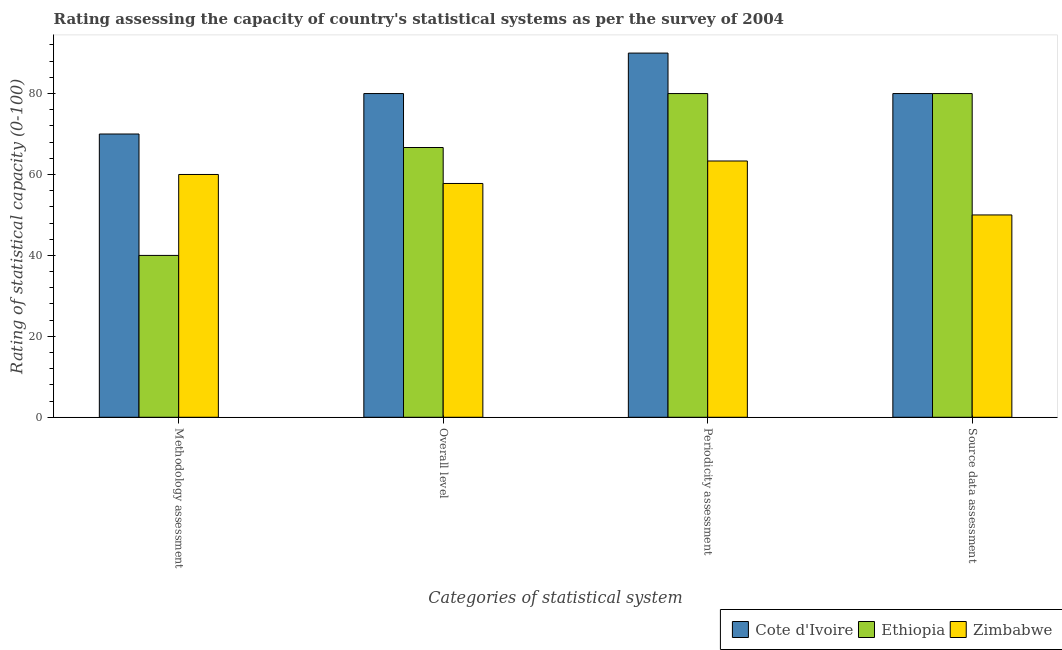How many groups of bars are there?
Provide a succinct answer. 4. Are the number of bars on each tick of the X-axis equal?
Your answer should be compact. Yes. What is the label of the 1st group of bars from the left?
Provide a succinct answer. Methodology assessment. What is the overall level rating in Ethiopia?
Keep it short and to the point. 66.67. Across all countries, what is the maximum source data assessment rating?
Make the answer very short. 80. Across all countries, what is the minimum source data assessment rating?
Provide a short and direct response. 50. In which country was the methodology assessment rating maximum?
Ensure brevity in your answer.  Cote d'Ivoire. In which country was the source data assessment rating minimum?
Your response must be concise. Zimbabwe. What is the total periodicity assessment rating in the graph?
Give a very brief answer. 233.33. What is the difference between the periodicity assessment rating in Ethiopia and that in Zimbabwe?
Provide a succinct answer. 16.67. What is the average source data assessment rating per country?
Offer a very short reply. 70. Is the difference between the periodicity assessment rating in Zimbabwe and Cote d'Ivoire greater than the difference between the overall level rating in Zimbabwe and Cote d'Ivoire?
Ensure brevity in your answer.  No. What is the difference between the highest and the second highest overall level rating?
Provide a succinct answer. 13.33. What is the difference between the highest and the lowest overall level rating?
Offer a very short reply. 22.22. In how many countries, is the source data assessment rating greater than the average source data assessment rating taken over all countries?
Your answer should be compact. 2. What does the 2nd bar from the left in Source data assessment represents?
Your response must be concise. Ethiopia. What does the 3rd bar from the right in Periodicity assessment represents?
Your response must be concise. Cote d'Ivoire. Is it the case that in every country, the sum of the methodology assessment rating and overall level rating is greater than the periodicity assessment rating?
Offer a terse response. Yes. Are all the bars in the graph horizontal?
Provide a short and direct response. No. How many countries are there in the graph?
Your answer should be compact. 3. What is the difference between two consecutive major ticks on the Y-axis?
Your answer should be compact. 20. Are the values on the major ticks of Y-axis written in scientific E-notation?
Your answer should be compact. No. Does the graph contain any zero values?
Give a very brief answer. No. Does the graph contain grids?
Offer a very short reply. No. What is the title of the graph?
Offer a terse response. Rating assessing the capacity of country's statistical systems as per the survey of 2004 . What is the label or title of the X-axis?
Keep it short and to the point. Categories of statistical system. What is the label or title of the Y-axis?
Your answer should be very brief. Rating of statistical capacity (0-100). What is the Rating of statistical capacity (0-100) in Cote d'Ivoire in Methodology assessment?
Give a very brief answer. 70. What is the Rating of statistical capacity (0-100) in Ethiopia in Methodology assessment?
Ensure brevity in your answer.  40. What is the Rating of statistical capacity (0-100) of Ethiopia in Overall level?
Keep it short and to the point. 66.67. What is the Rating of statistical capacity (0-100) of Zimbabwe in Overall level?
Ensure brevity in your answer.  57.78. What is the Rating of statistical capacity (0-100) in Cote d'Ivoire in Periodicity assessment?
Your response must be concise. 90. What is the Rating of statistical capacity (0-100) of Zimbabwe in Periodicity assessment?
Provide a short and direct response. 63.33. What is the Rating of statistical capacity (0-100) of Zimbabwe in Source data assessment?
Your answer should be very brief. 50. Across all Categories of statistical system, what is the maximum Rating of statistical capacity (0-100) in Cote d'Ivoire?
Provide a short and direct response. 90. Across all Categories of statistical system, what is the maximum Rating of statistical capacity (0-100) in Ethiopia?
Offer a very short reply. 80. Across all Categories of statistical system, what is the maximum Rating of statistical capacity (0-100) in Zimbabwe?
Provide a short and direct response. 63.33. Across all Categories of statistical system, what is the minimum Rating of statistical capacity (0-100) of Cote d'Ivoire?
Make the answer very short. 70. Across all Categories of statistical system, what is the minimum Rating of statistical capacity (0-100) in Ethiopia?
Give a very brief answer. 40. Across all Categories of statistical system, what is the minimum Rating of statistical capacity (0-100) in Zimbabwe?
Offer a terse response. 50. What is the total Rating of statistical capacity (0-100) in Cote d'Ivoire in the graph?
Make the answer very short. 320. What is the total Rating of statistical capacity (0-100) in Ethiopia in the graph?
Provide a succinct answer. 266.67. What is the total Rating of statistical capacity (0-100) of Zimbabwe in the graph?
Your answer should be very brief. 231.11. What is the difference between the Rating of statistical capacity (0-100) of Ethiopia in Methodology assessment and that in Overall level?
Ensure brevity in your answer.  -26.67. What is the difference between the Rating of statistical capacity (0-100) in Zimbabwe in Methodology assessment and that in Overall level?
Provide a short and direct response. 2.22. What is the difference between the Rating of statistical capacity (0-100) of Cote d'Ivoire in Methodology assessment and that in Periodicity assessment?
Ensure brevity in your answer.  -20. What is the difference between the Rating of statistical capacity (0-100) of Ethiopia in Methodology assessment and that in Periodicity assessment?
Ensure brevity in your answer.  -40. What is the difference between the Rating of statistical capacity (0-100) in Cote d'Ivoire in Methodology assessment and that in Source data assessment?
Give a very brief answer. -10. What is the difference between the Rating of statistical capacity (0-100) of Ethiopia in Overall level and that in Periodicity assessment?
Offer a very short reply. -13.33. What is the difference between the Rating of statistical capacity (0-100) of Zimbabwe in Overall level and that in Periodicity assessment?
Provide a succinct answer. -5.56. What is the difference between the Rating of statistical capacity (0-100) of Ethiopia in Overall level and that in Source data assessment?
Your answer should be very brief. -13.33. What is the difference between the Rating of statistical capacity (0-100) in Zimbabwe in Overall level and that in Source data assessment?
Provide a short and direct response. 7.78. What is the difference between the Rating of statistical capacity (0-100) of Zimbabwe in Periodicity assessment and that in Source data assessment?
Provide a short and direct response. 13.33. What is the difference between the Rating of statistical capacity (0-100) in Cote d'Ivoire in Methodology assessment and the Rating of statistical capacity (0-100) in Ethiopia in Overall level?
Your answer should be very brief. 3.33. What is the difference between the Rating of statistical capacity (0-100) of Cote d'Ivoire in Methodology assessment and the Rating of statistical capacity (0-100) of Zimbabwe in Overall level?
Offer a very short reply. 12.22. What is the difference between the Rating of statistical capacity (0-100) in Ethiopia in Methodology assessment and the Rating of statistical capacity (0-100) in Zimbabwe in Overall level?
Your answer should be very brief. -17.78. What is the difference between the Rating of statistical capacity (0-100) of Cote d'Ivoire in Methodology assessment and the Rating of statistical capacity (0-100) of Zimbabwe in Periodicity assessment?
Give a very brief answer. 6.67. What is the difference between the Rating of statistical capacity (0-100) of Ethiopia in Methodology assessment and the Rating of statistical capacity (0-100) of Zimbabwe in Periodicity assessment?
Provide a short and direct response. -23.33. What is the difference between the Rating of statistical capacity (0-100) of Cote d'Ivoire in Methodology assessment and the Rating of statistical capacity (0-100) of Zimbabwe in Source data assessment?
Provide a short and direct response. 20. What is the difference between the Rating of statistical capacity (0-100) in Cote d'Ivoire in Overall level and the Rating of statistical capacity (0-100) in Ethiopia in Periodicity assessment?
Make the answer very short. 0. What is the difference between the Rating of statistical capacity (0-100) in Cote d'Ivoire in Overall level and the Rating of statistical capacity (0-100) in Zimbabwe in Periodicity assessment?
Provide a short and direct response. 16.67. What is the difference between the Rating of statistical capacity (0-100) of Ethiopia in Overall level and the Rating of statistical capacity (0-100) of Zimbabwe in Periodicity assessment?
Your response must be concise. 3.33. What is the difference between the Rating of statistical capacity (0-100) of Ethiopia in Overall level and the Rating of statistical capacity (0-100) of Zimbabwe in Source data assessment?
Make the answer very short. 16.67. What is the difference between the Rating of statistical capacity (0-100) in Cote d'Ivoire in Periodicity assessment and the Rating of statistical capacity (0-100) in Zimbabwe in Source data assessment?
Ensure brevity in your answer.  40. What is the average Rating of statistical capacity (0-100) of Ethiopia per Categories of statistical system?
Make the answer very short. 66.67. What is the average Rating of statistical capacity (0-100) in Zimbabwe per Categories of statistical system?
Your answer should be very brief. 57.78. What is the difference between the Rating of statistical capacity (0-100) of Cote d'Ivoire and Rating of statistical capacity (0-100) of Zimbabwe in Methodology assessment?
Your answer should be very brief. 10. What is the difference between the Rating of statistical capacity (0-100) in Cote d'Ivoire and Rating of statistical capacity (0-100) in Ethiopia in Overall level?
Give a very brief answer. 13.33. What is the difference between the Rating of statistical capacity (0-100) of Cote d'Ivoire and Rating of statistical capacity (0-100) of Zimbabwe in Overall level?
Your answer should be very brief. 22.22. What is the difference between the Rating of statistical capacity (0-100) of Ethiopia and Rating of statistical capacity (0-100) of Zimbabwe in Overall level?
Give a very brief answer. 8.89. What is the difference between the Rating of statistical capacity (0-100) of Cote d'Ivoire and Rating of statistical capacity (0-100) of Ethiopia in Periodicity assessment?
Your answer should be very brief. 10. What is the difference between the Rating of statistical capacity (0-100) of Cote d'Ivoire and Rating of statistical capacity (0-100) of Zimbabwe in Periodicity assessment?
Your response must be concise. 26.67. What is the difference between the Rating of statistical capacity (0-100) in Ethiopia and Rating of statistical capacity (0-100) in Zimbabwe in Periodicity assessment?
Make the answer very short. 16.67. What is the difference between the Rating of statistical capacity (0-100) of Ethiopia and Rating of statistical capacity (0-100) of Zimbabwe in Source data assessment?
Provide a short and direct response. 30. What is the ratio of the Rating of statistical capacity (0-100) in Cote d'Ivoire in Methodology assessment to that in Overall level?
Provide a short and direct response. 0.88. What is the ratio of the Rating of statistical capacity (0-100) of Ethiopia in Methodology assessment to that in Overall level?
Provide a succinct answer. 0.6. What is the ratio of the Rating of statistical capacity (0-100) of Zimbabwe in Methodology assessment to that in Periodicity assessment?
Ensure brevity in your answer.  0.95. What is the ratio of the Rating of statistical capacity (0-100) of Cote d'Ivoire in Methodology assessment to that in Source data assessment?
Your response must be concise. 0.88. What is the ratio of the Rating of statistical capacity (0-100) in Zimbabwe in Overall level to that in Periodicity assessment?
Offer a terse response. 0.91. What is the ratio of the Rating of statistical capacity (0-100) of Cote d'Ivoire in Overall level to that in Source data assessment?
Make the answer very short. 1. What is the ratio of the Rating of statistical capacity (0-100) of Zimbabwe in Overall level to that in Source data assessment?
Make the answer very short. 1.16. What is the ratio of the Rating of statistical capacity (0-100) of Cote d'Ivoire in Periodicity assessment to that in Source data assessment?
Your response must be concise. 1.12. What is the ratio of the Rating of statistical capacity (0-100) of Ethiopia in Periodicity assessment to that in Source data assessment?
Your answer should be very brief. 1. What is the ratio of the Rating of statistical capacity (0-100) in Zimbabwe in Periodicity assessment to that in Source data assessment?
Provide a succinct answer. 1.27. What is the difference between the highest and the second highest Rating of statistical capacity (0-100) in Ethiopia?
Offer a very short reply. 0. What is the difference between the highest and the lowest Rating of statistical capacity (0-100) of Cote d'Ivoire?
Offer a terse response. 20. What is the difference between the highest and the lowest Rating of statistical capacity (0-100) in Zimbabwe?
Provide a succinct answer. 13.33. 